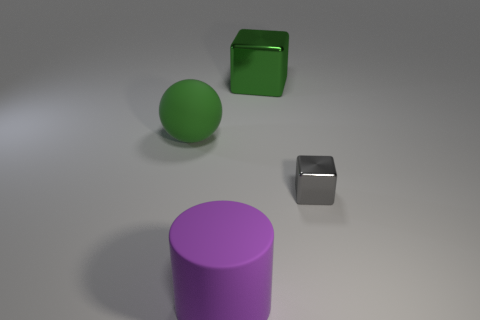What color is the metal block that is to the right of the large metallic thing?
Ensure brevity in your answer.  Gray. What is the large thing that is behind the purple rubber cylinder and in front of the large block made of?
Your answer should be compact. Rubber. There is a big green ball that is left of the large purple object; what number of green matte things are left of it?
Ensure brevity in your answer.  0. There is a gray thing; what shape is it?
Offer a terse response. Cube. There is a object that is made of the same material as the small cube; what is its shape?
Your answer should be very brief. Cube. There is a shiny object behind the tiny object; is it the same shape as the gray metal object?
Your answer should be very brief. Yes. What shape is the big green object on the left side of the large green block?
Provide a succinct answer. Sphere. There is a big metallic object that is the same color as the big ball; what is its shape?
Keep it short and to the point. Cube. How many blue rubber cubes are the same size as the green metal block?
Offer a terse response. 0. What is the color of the big ball?
Your response must be concise. Green. 